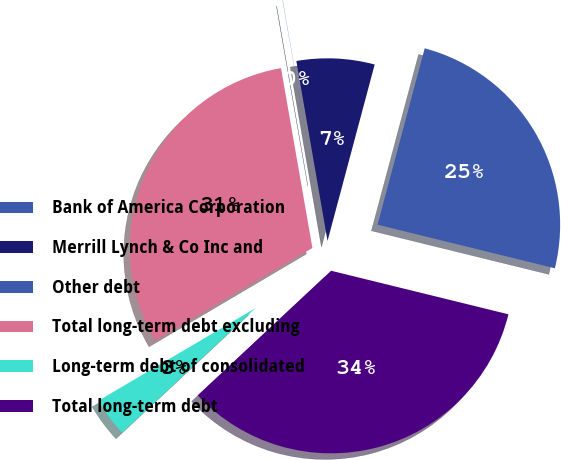Convert chart. <chart><loc_0><loc_0><loc_500><loc_500><pie_chart><fcel>Bank of America Corporation<fcel>Merrill Lynch & Co Inc and<fcel>Other debt<fcel>Total long-term debt excluding<fcel>Long-term debt of consolidated<fcel>Total long-term debt<nl><fcel>24.68%<fcel>6.89%<fcel>0.02%<fcel>30.73%<fcel>3.48%<fcel>34.21%<nl></chart> 